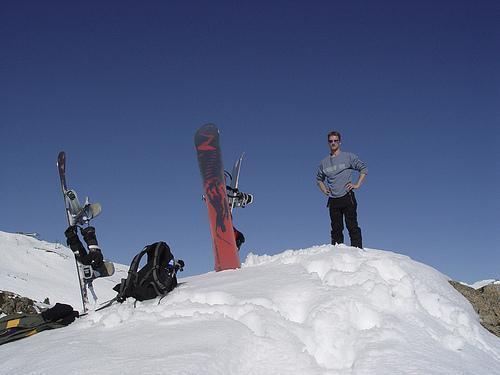How many snowboards can you see?
Give a very brief answer. 2. How many sinks are in the bathroom?
Give a very brief answer. 0. 